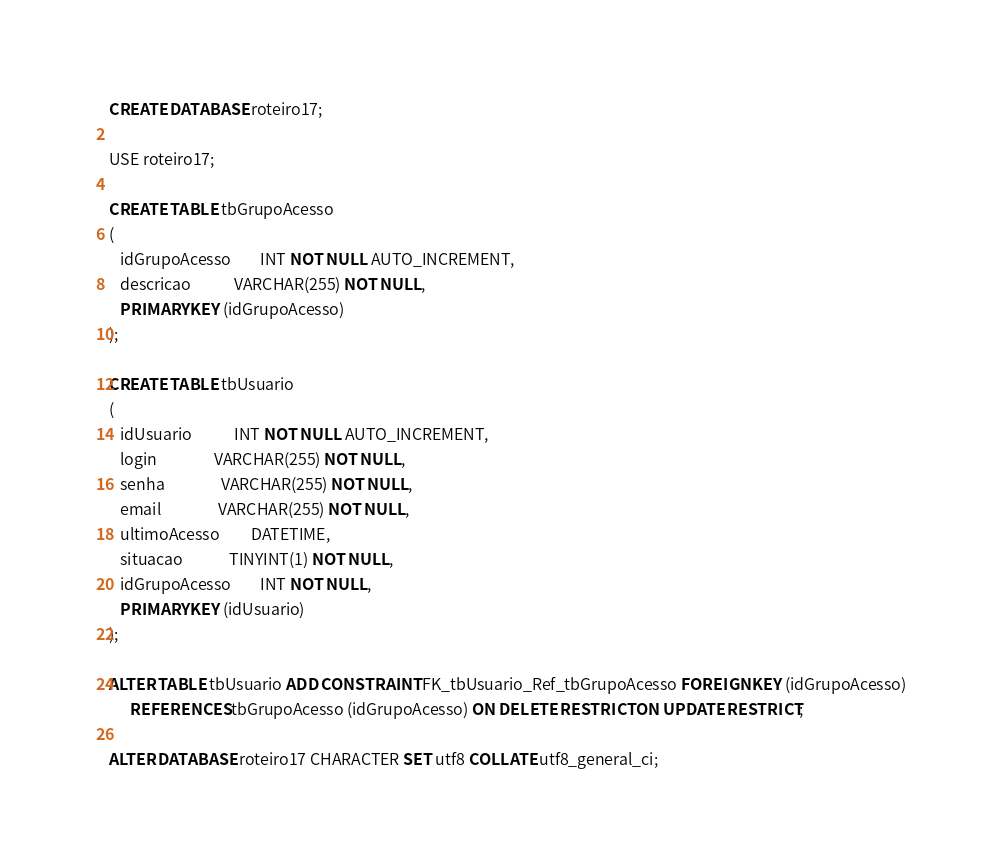<code> <loc_0><loc_0><loc_500><loc_500><_SQL_>CREATE DATABASE roteiro17;

USE roteiro17;

CREATE TABLE tbGrupoAcesso
(
   idGrupoAcesso        INT NOT NULL AUTO_INCREMENT,
   descricao            VARCHAR(255) NOT NULL,
   PRIMARY KEY (idGrupoAcesso)
);

CREATE TABLE tbUsuario
(
   idUsuario            INT NOT NULL AUTO_INCREMENT,
   login                VARCHAR(255) NOT NULL,
   senha                VARCHAR(255) NOT NULL,
   email                VARCHAR(255) NOT NULL,
   ultimoAcesso         DATETIME,
   situacao             TINYINT(1) NOT NULL,
   idGrupoAcesso        INT NOT NULL,
   PRIMARY KEY (idUsuario)
);

ALTER TABLE tbUsuario ADD CONSTRAINT FK_tbUsuario_Ref_tbGrupoAcesso FOREIGN KEY (idGrupoAcesso)
      REFERENCES tbGrupoAcesso (idGrupoAcesso) ON DELETE RESTRICT ON UPDATE RESTRICT;

ALTER DATABASE roteiro17 CHARACTER SET utf8 COLLATE utf8_general_ci;</code> 